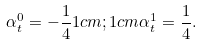<formula> <loc_0><loc_0><loc_500><loc_500>\alpha _ { t } ^ { 0 } = - \frac { 1 } { 4 } 1 c m ; 1 c m \alpha _ { t } ^ { 1 } = \frac { 1 } { 4 } .</formula> 